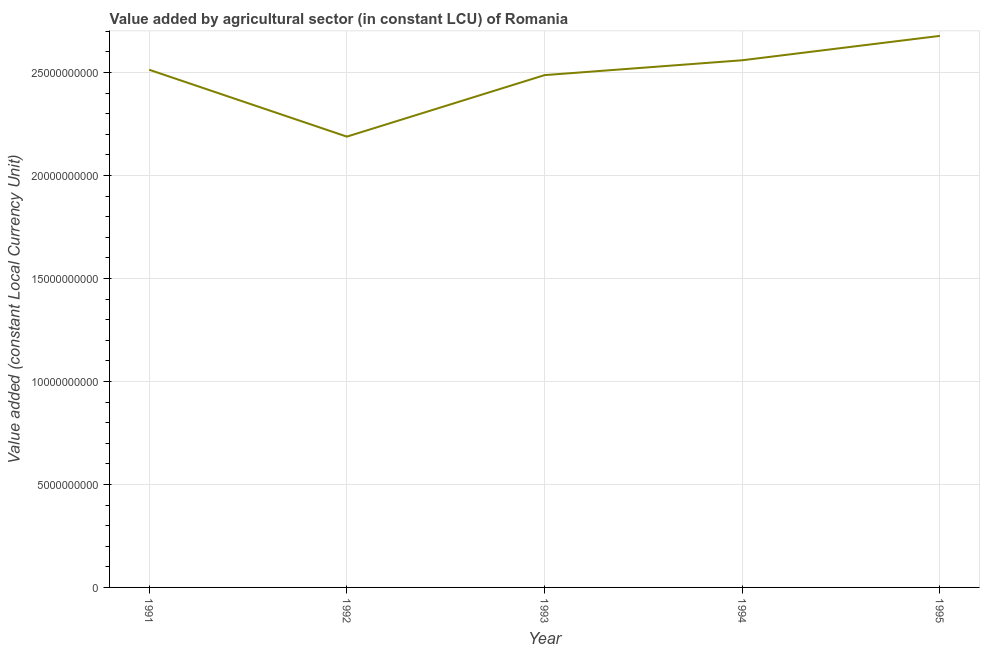What is the value added by agriculture sector in 1991?
Make the answer very short. 2.51e+1. Across all years, what is the maximum value added by agriculture sector?
Your answer should be very brief. 2.68e+1. Across all years, what is the minimum value added by agriculture sector?
Offer a very short reply. 2.19e+1. In which year was the value added by agriculture sector minimum?
Give a very brief answer. 1992. What is the sum of the value added by agriculture sector?
Keep it short and to the point. 1.24e+11. What is the difference between the value added by agriculture sector in 1992 and 1995?
Your answer should be compact. -4.89e+09. What is the average value added by agriculture sector per year?
Your answer should be very brief. 2.49e+1. What is the median value added by agriculture sector?
Give a very brief answer. 2.51e+1. Do a majority of the years between 1995 and 1994 (inclusive) have value added by agriculture sector greater than 25000000000 LCU?
Ensure brevity in your answer.  No. What is the ratio of the value added by agriculture sector in 1992 to that in 1993?
Your response must be concise. 0.88. Is the difference between the value added by agriculture sector in 1991 and 1993 greater than the difference between any two years?
Your response must be concise. No. What is the difference between the highest and the second highest value added by agriculture sector?
Offer a terse response. 1.18e+09. What is the difference between the highest and the lowest value added by agriculture sector?
Give a very brief answer. 4.89e+09. How many years are there in the graph?
Ensure brevity in your answer.  5. Are the values on the major ticks of Y-axis written in scientific E-notation?
Your response must be concise. No. Does the graph contain any zero values?
Provide a succinct answer. No. Does the graph contain grids?
Provide a succinct answer. Yes. What is the title of the graph?
Ensure brevity in your answer.  Value added by agricultural sector (in constant LCU) of Romania. What is the label or title of the Y-axis?
Your response must be concise. Value added (constant Local Currency Unit). What is the Value added (constant Local Currency Unit) of 1991?
Ensure brevity in your answer.  2.51e+1. What is the Value added (constant Local Currency Unit) of 1992?
Give a very brief answer. 2.19e+1. What is the Value added (constant Local Currency Unit) of 1993?
Give a very brief answer. 2.49e+1. What is the Value added (constant Local Currency Unit) of 1994?
Offer a terse response. 2.56e+1. What is the Value added (constant Local Currency Unit) of 1995?
Offer a terse response. 2.68e+1. What is the difference between the Value added (constant Local Currency Unit) in 1991 and 1992?
Provide a short and direct response. 3.25e+09. What is the difference between the Value added (constant Local Currency Unit) in 1991 and 1993?
Keep it short and to the point. 2.62e+08. What is the difference between the Value added (constant Local Currency Unit) in 1991 and 1994?
Your answer should be compact. -4.60e+08. What is the difference between the Value added (constant Local Currency Unit) in 1991 and 1995?
Your answer should be compact. -1.64e+09. What is the difference between the Value added (constant Local Currency Unit) in 1992 and 1993?
Your response must be concise. -2.99e+09. What is the difference between the Value added (constant Local Currency Unit) in 1992 and 1994?
Offer a very short reply. -3.71e+09. What is the difference between the Value added (constant Local Currency Unit) in 1992 and 1995?
Make the answer very short. -4.89e+09. What is the difference between the Value added (constant Local Currency Unit) in 1993 and 1994?
Provide a short and direct response. -7.22e+08. What is the difference between the Value added (constant Local Currency Unit) in 1993 and 1995?
Your answer should be compact. -1.91e+09. What is the difference between the Value added (constant Local Currency Unit) in 1994 and 1995?
Ensure brevity in your answer.  -1.18e+09. What is the ratio of the Value added (constant Local Currency Unit) in 1991 to that in 1992?
Keep it short and to the point. 1.15. What is the ratio of the Value added (constant Local Currency Unit) in 1991 to that in 1995?
Give a very brief answer. 0.94. What is the ratio of the Value added (constant Local Currency Unit) in 1992 to that in 1993?
Ensure brevity in your answer.  0.88. What is the ratio of the Value added (constant Local Currency Unit) in 1992 to that in 1994?
Your answer should be very brief. 0.85. What is the ratio of the Value added (constant Local Currency Unit) in 1992 to that in 1995?
Your answer should be very brief. 0.82. What is the ratio of the Value added (constant Local Currency Unit) in 1993 to that in 1995?
Provide a short and direct response. 0.93. What is the ratio of the Value added (constant Local Currency Unit) in 1994 to that in 1995?
Your answer should be very brief. 0.96. 